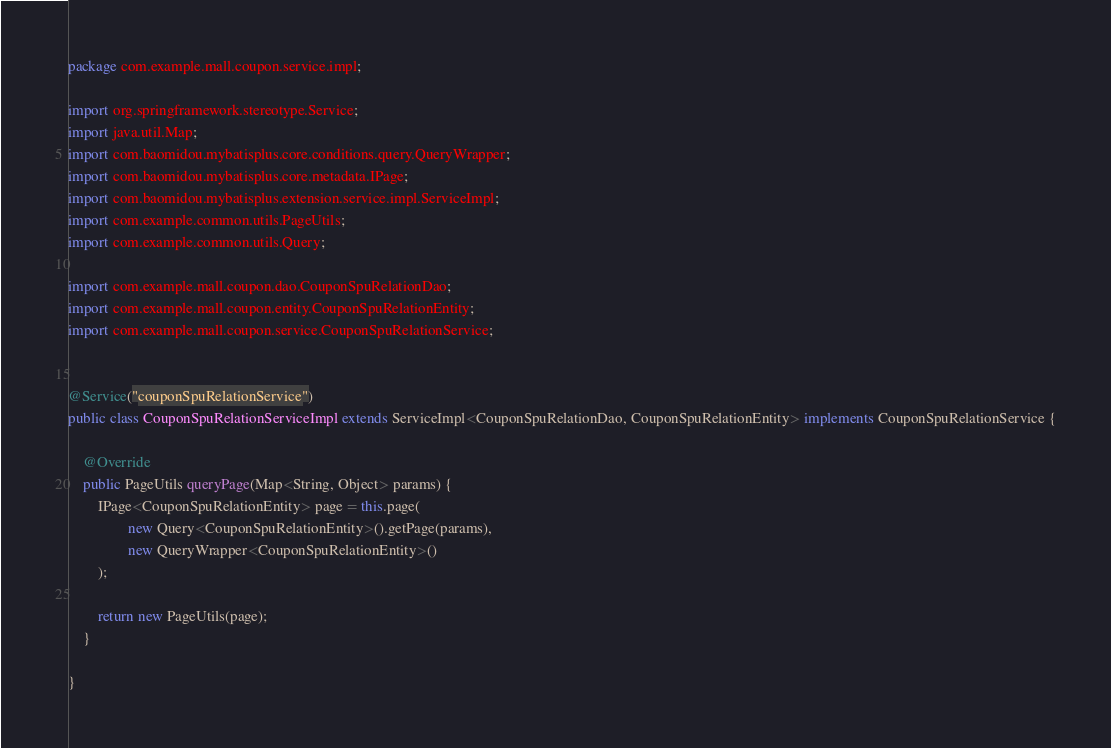<code> <loc_0><loc_0><loc_500><loc_500><_Java_>package com.example.mall.coupon.service.impl;

import org.springframework.stereotype.Service;
import java.util.Map;
import com.baomidou.mybatisplus.core.conditions.query.QueryWrapper;
import com.baomidou.mybatisplus.core.metadata.IPage;
import com.baomidou.mybatisplus.extension.service.impl.ServiceImpl;
import com.example.common.utils.PageUtils;
import com.example.common.utils.Query;

import com.example.mall.coupon.dao.CouponSpuRelationDao;
import com.example.mall.coupon.entity.CouponSpuRelationEntity;
import com.example.mall.coupon.service.CouponSpuRelationService;


@Service("couponSpuRelationService")
public class CouponSpuRelationServiceImpl extends ServiceImpl<CouponSpuRelationDao, CouponSpuRelationEntity> implements CouponSpuRelationService {

    @Override
    public PageUtils queryPage(Map<String, Object> params) {
        IPage<CouponSpuRelationEntity> page = this.page(
                new Query<CouponSpuRelationEntity>().getPage(params),
                new QueryWrapper<CouponSpuRelationEntity>()
        );

        return new PageUtils(page);
    }

}</code> 